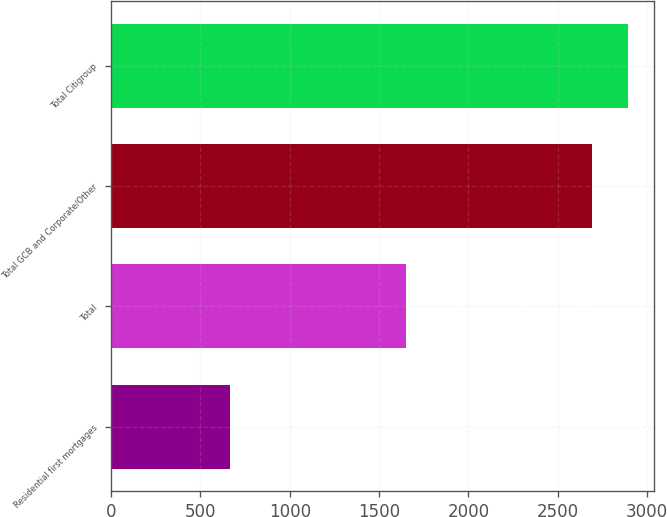Convert chart. <chart><loc_0><loc_0><loc_500><loc_500><bar_chart><fcel>Residential first mortgages<fcel>Total<fcel>Total GCB and Corporate/Other<fcel>Total Citigroup<nl><fcel>665<fcel>1650<fcel>2690<fcel>2892.5<nl></chart> 